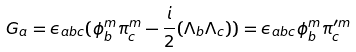Convert formula to latex. <formula><loc_0><loc_0><loc_500><loc_500>G _ { a } = \epsilon _ { a b c } ( \phi ^ { m } _ { b } \pi ^ { m } _ { c } - \frac { i } { 2 } ( \Lambda _ { b } \Lambda _ { c } ) ) = \epsilon _ { a b c } \phi ^ { m } _ { b } \pi ^ { \prime m } _ { c }</formula> 